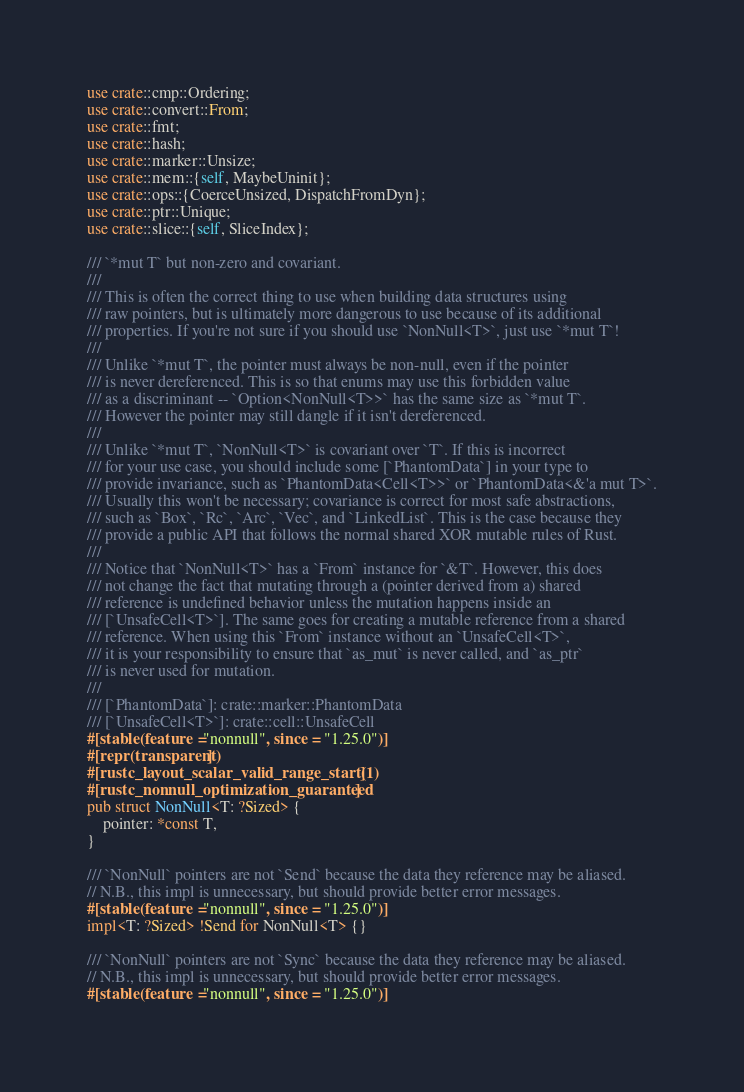<code> <loc_0><loc_0><loc_500><loc_500><_Rust_>use crate::cmp::Ordering;
use crate::convert::From;
use crate::fmt;
use crate::hash;
use crate::marker::Unsize;
use crate::mem::{self, MaybeUninit};
use crate::ops::{CoerceUnsized, DispatchFromDyn};
use crate::ptr::Unique;
use crate::slice::{self, SliceIndex};

/// `*mut T` but non-zero and covariant.
///
/// This is often the correct thing to use when building data structures using
/// raw pointers, but is ultimately more dangerous to use because of its additional
/// properties. If you're not sure if you should use `NonNull<T>`, just use `*mut T`!
///
/// Unlike `*mut T`, the pointer must always be non-null, even if the pointer
/// is never dereferenced. This is so that enums may use this forbidden value
/// as a discriminant -- `Option<NonNull<T>>` has the same size as `*mut T`.
/// However the pointer may still dangle if it isn't dereferenced.
///
/// Unlike `*mut T`, `NonNull<T>` is covariant over `T`. If this is incorrect
/// for your use case, you should include some [`PhantomData`] in your type to
/// provide invariance, such as `PhantomData<Cell<T>>` or `PhantomData<&'a mut T>`.
/// Usually this won't be necessary; covariance is correct for most safe abstractions,
/// such as `Box`, `Rc`, `Arc`, `Vec`, and `LinkedList`. This is the case because they
/// provide a public API that follows the normal shared XOR mutable rules of Rust.
///
/// Notice that `NonNull<T>` has a `From` instance for `&T`. However, this does
/// not change the fact that mutating through a (pointer derived from a) shared
/// reference is undefined behavior unless the mutation happens inside an
/// [`UnsafeCell<T>`]. The same goes for creating a mutable reference from a shared
/// reference. When using this `From` instance without an `UnsafeCell<T>`,
/// it is your responsibility to ensure that `as_mut` is never called, and `as_ptr`
/// is never used for mutation.
///
/// [`PhantomData`]: crate::marker::PhantomData
/// [`UnsafeCell<T>`]: crate::cell::UnsafeCell
#[stable(feature = "nonnull", since = "1.25.0")]
#[repr(transparent)]
#[rustc_layout_scalar_valid_range_start(1)]
#[rustc_nonnull_optimization_guaranteed]
pub struct NonNull<T: ?Sized> {
    pointer: *const T,
}

/// `NonNull` pointers are not `Send` because the data they reference may be aliased.
// N.B., this impl is unnecessary, but should provide better error messages.
#[stable(feature = "nonnull", since = "1.25.0")]
impl<T: ?Sized> !Send for NonNull<T> {}

/// `NonNull` pointers are not `Sync` because the data they reference may be aliased.
// N.B., this impl is unnecessary, but should provide better error messages.
#[stable(feature = "nonnull", since = "1.25.0")]</code> 